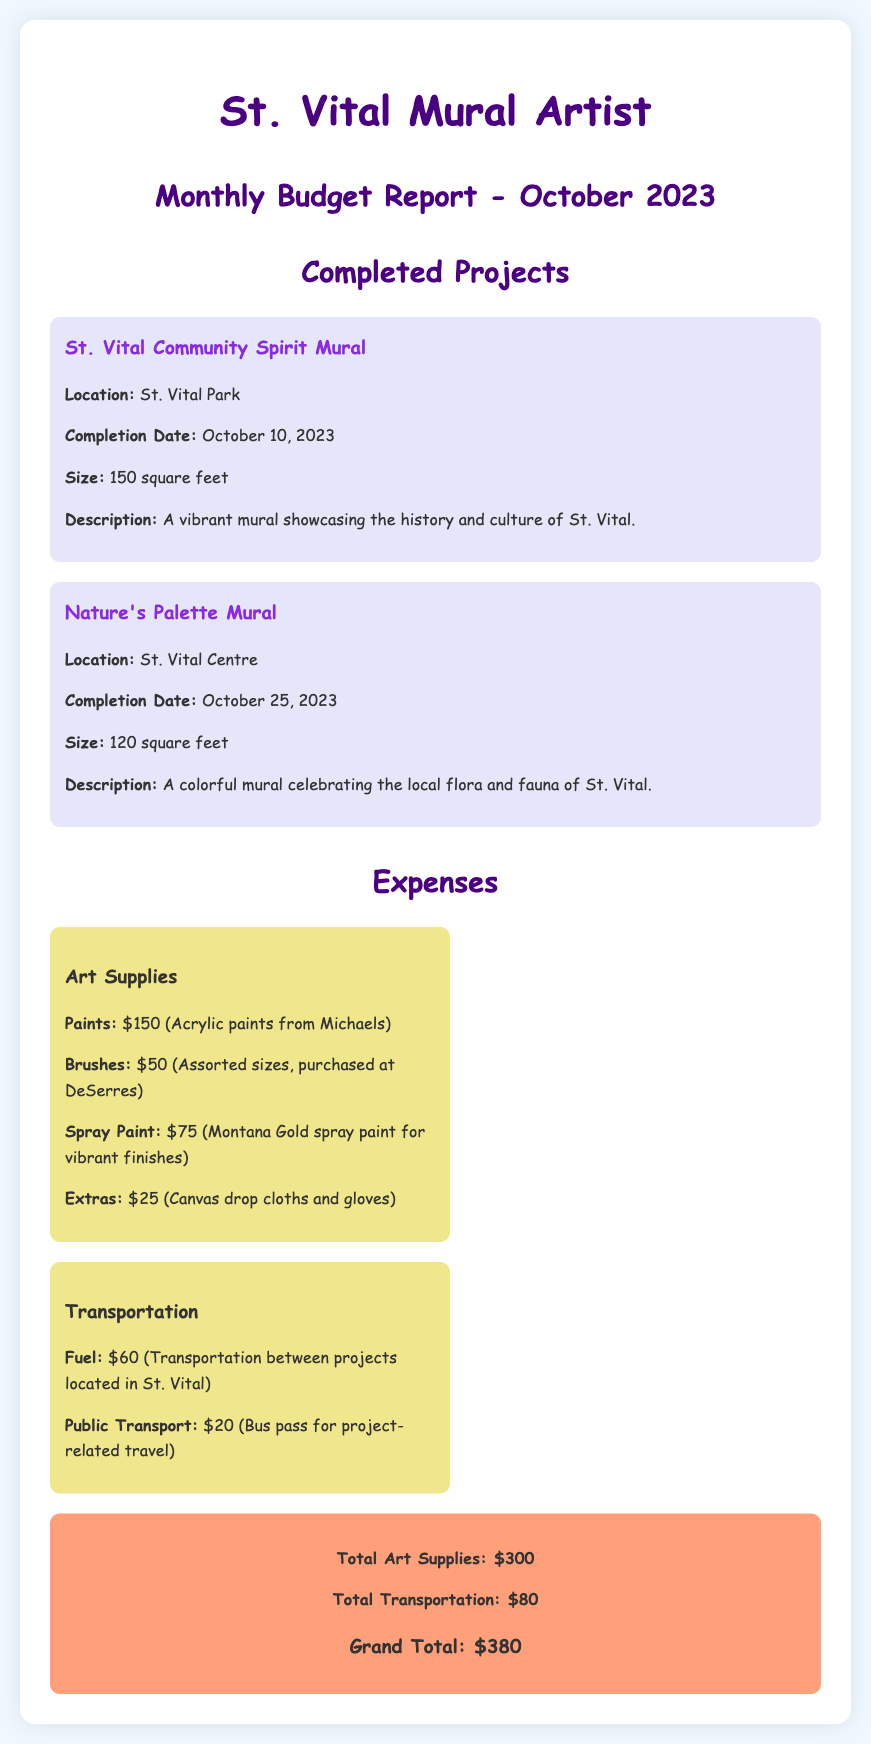What is the completion date of the St. Vital Community Spirit Mural? The completion date is specified in the project section of the document, which states October 10, 2023.
Answer: October 10, 2023 How much did the paints cost? The expense category for art supplies lists the cost of paints as $150.
Answer: $150 What was the total expense for transportation? The total transportation costs are summarized in the document, adding up to $80.
Answer: $80 Which mural was completed last? The completion dates were mentioned, and the last project completed is Nature's Palette Mural on October 25, 2023.
Answer: Nature's Palette Mural What is the grand total of all expenses? The grand total is presented at the end of the expenses section, combining total art supplies and transportation.
Answer: $380 What location is the St. Vital Community Spirit Mural in? The document specifies the location as St. Vital Park.
Answer: St. Vital Park How many square feet is the Nature's Palette Mural? The size of the Nature's Palette Mural is provided as 120 square feet in the project description.
Answer: 120 square feet What type of paint was mentioned for use in the projects? The document highlights that acrylic paints from Michaels were used in the projects under art supplies.
Answer: Acrylic paints What is the total cost of extras for art supplies? The expense details indicate that the extras cost $25.
Answer: $25 